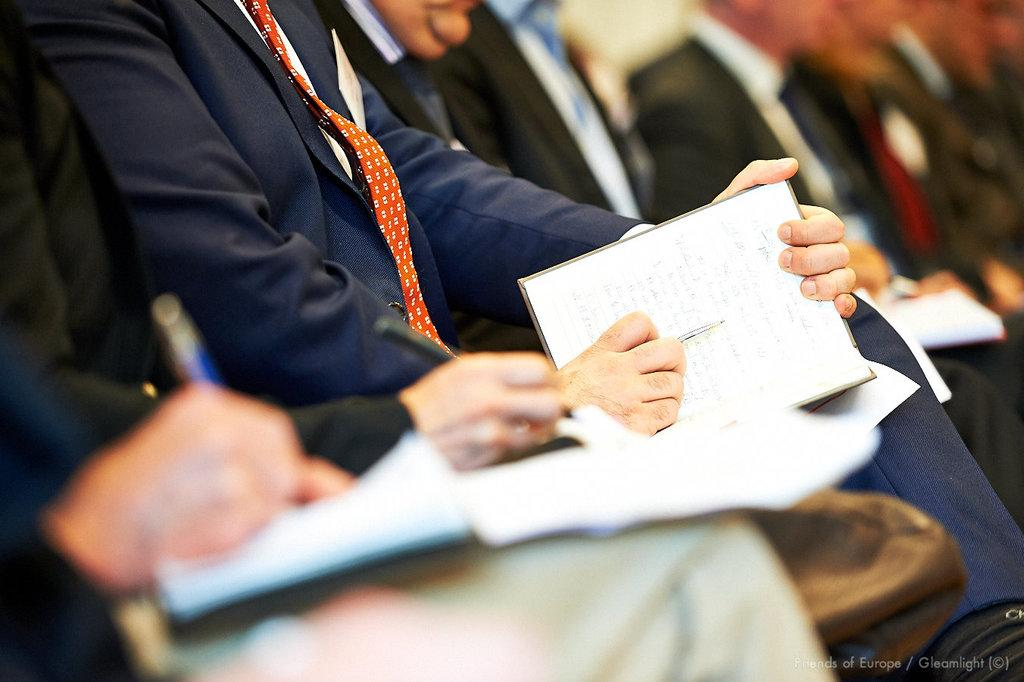What are the people in the image doing? The people in the image are sitting and holding books. In which direction are the people facing? The people are facing towards the right side. What else are the people holding in the image? The people are also holding pens. What type of crime is being committed in the image? There is no indication of any crime being committed in the image; the people are simply sitting and holding books and pens. 